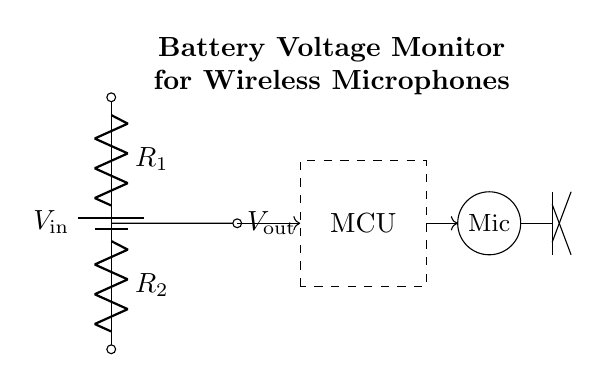What is the input voltage of the circuit? The battery in the circuit is labeled as V_in, but the actual voltage value is not specified in this diagram. Typically, a standard battery voltage could be 1.5V, 9V, or another value based on application.
Answer: V_in What are the resistances used in the voltage divider? The circuit shows two resistors labeled R1 and R2. Their exact values are not shown in the diagram, but both components are crucial in determining the output voltage from the input voltage in a voltage divider configuration.
Answer: R1 and R2 What is the output voltage labeled in the circuit? The output voltage is represented as V_out, which comes from the point between the two resistors in the voltage divider. The exact value is calculated based on the values of R1, R2, and V_in using the formula V_out = V_in * (R2 / (R1 + R2)).
Answer: V_out Which component indicates the wireless microphone? The microphone in the circuit is depicted as a small circle with the label "Mic". This is where the processed voltage will be applied to the microphone for it to function correctly during team performances.
Answer: Mic How is the microcontroller connected to the circuit? The microcontroller (MCU) is shown as a dashed rectangle, connected by an arrow indicating data or power flow from the voltage divider output, which is crucial for monitoring the battery status and controlling the microphone functions.
Answer: Through an arrow Why is a voltage divider used in this circuit? The voltage divider's purpose is to provide a compatible voltage to the wireless microphone that is lower than the input voltage from the battery. This ensures that the microphone receives the correct operating voltage without exceeding its rated maximum voltage.
Answer: To reduce voltage 